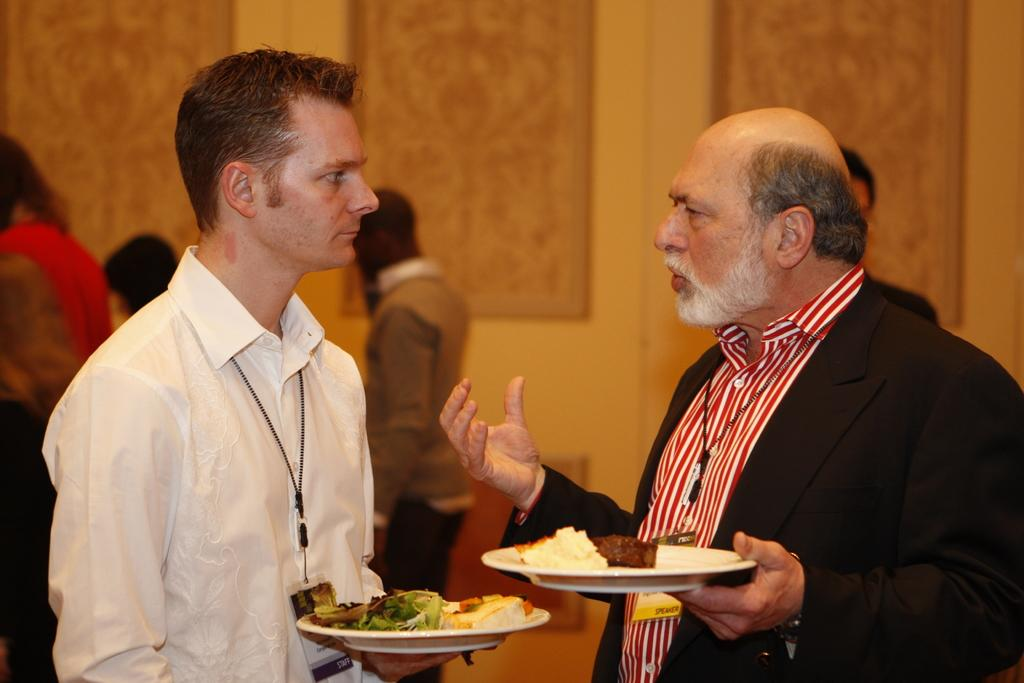How many men are present in the image? There are two men standing in the image. What are the men holding in their hands? The men are holding plates in their hands. Can you describe the background of the image? There are people standing in the background of the image, and there is a wall visible as well. What type of pen is the man using to sign his degree in the image? There is no pen or degree present in the image; it only features two men holding plates and people standing in the background. 